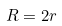<formula> <loc_0><loc_0><loc_500><loc_500>R = 2 r</formula> 